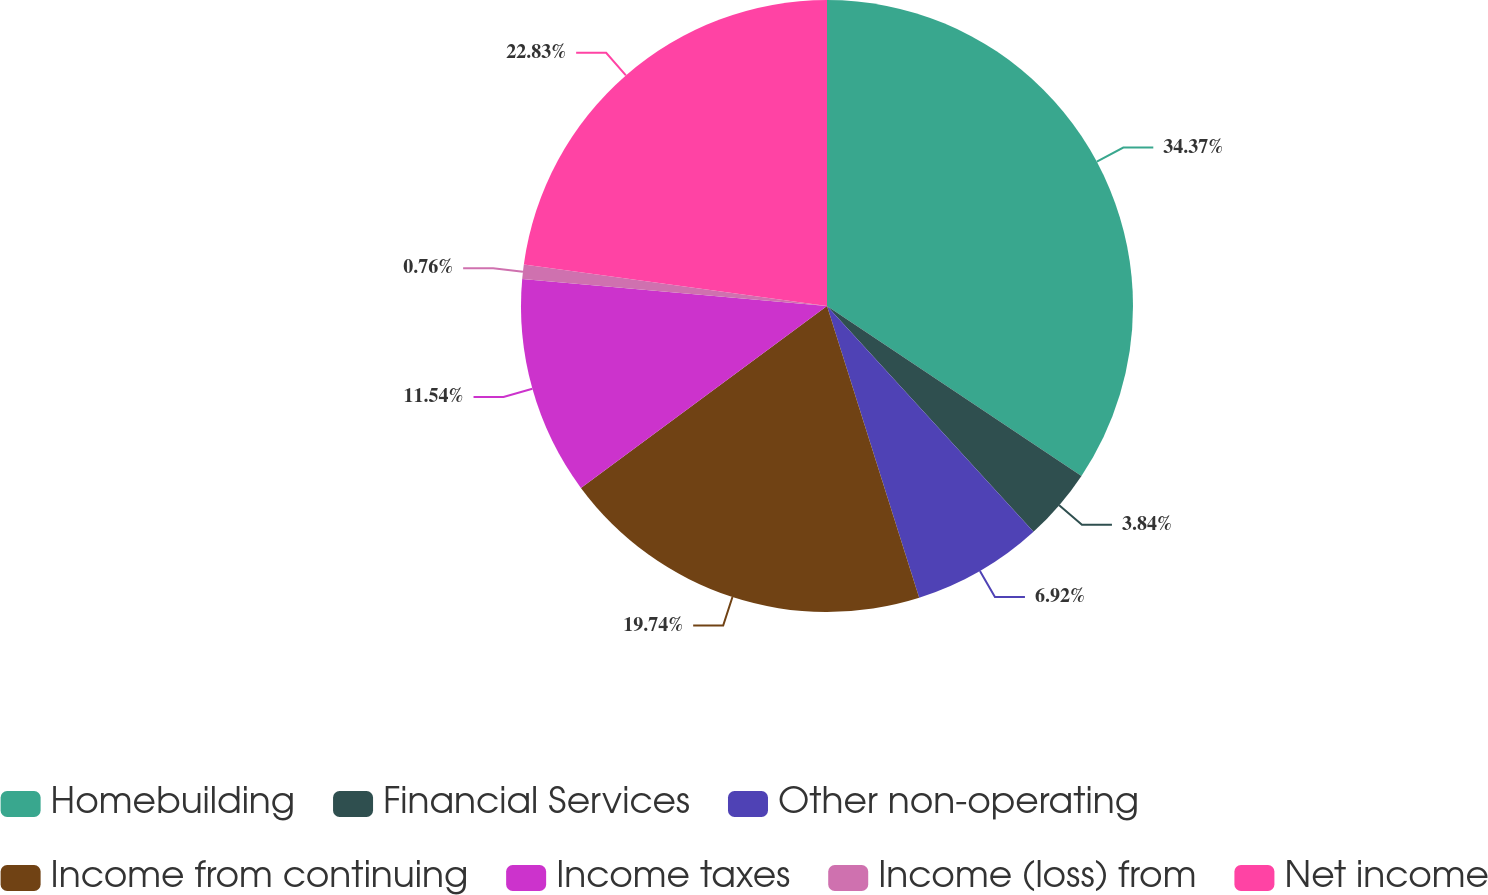Convert chart. <chart><loc_0><loc_0><loc_500><loc_500><pie_chart><fcel>Homebuilding<fcel>Financial Services<fcel>Other non-operating<fcel>Income from continuing<fcel>Income taxes<fcel>Income (loss) from<fcel>Net income<nl><fcel>34.37%<fcel>3.84%<fcel>6.92%<fcel>19.74%<fcel>11.54%<fcel>0.76%<fcel>22.83%<nl></chart> 